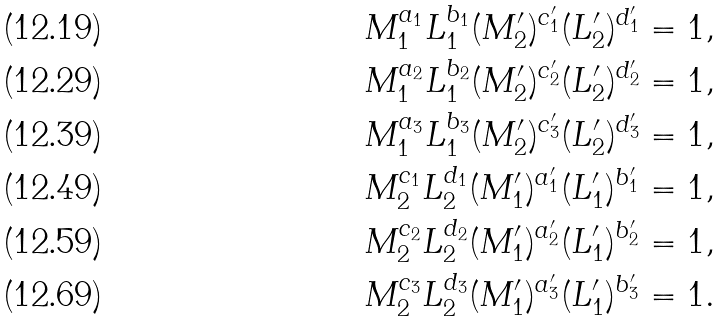Convert formula to latex. <formula><loc_0><loc_0><loc_500><loc_500>M _ { 1 } ^ { a _ { 1 } } L _ { 1 } ^ { b _ { 1 } } ( M ^ { \prime } _ { 2 } ) ^ { c ^ { \prime } _ { 1 } } ( L ^ { \prime } _ { 2 } ) ^ { d ^ { \prime } _ { 1 } } = 1 , \\ M _ { 1 } ^ { a _ { 2 } } L _ { 1 } ^ { b _ { 2 } } ( M ^ { \prime } _ { 2 } ) ^ { c ^ { \prime } _ { 2 } } ( L ^ { \prime } _ { 2 } ) ^ { d ^ { \prime } _ { 2 } } = 1 , \\ M _ { 1 } ^ { a _ { 3 } } L _ { 1 } ^ { b _ { 3 } } ( M ^ { \prime } _ { 2 } ) ^ { c ^ { \prime } _ { 3 } } ( L ^ { \prime } _ { 2 } ) ^ { d ^ { \prime } _ { 3 } } = 1 , \\ M _ { 2 } ^ { c _ { 1 } } L _ { 2 } ^ { d _ { 1 } } ( M ^ { \prime } _ { 1 } ) ^ { a ^ { \prime } _ { 1 } } ( L ^ { \prime } _ { 1 } ) ^ { b ^ { \prime } _ { 1 } } = 1 , \\ M _ { 2 } ^ { c _ { 2 } } L _ { 2 } ^ { d _ { 2 } } ( M ^ { \prime } _ { 1 } ) ^ { a ^ { \prime } _ { 2 } } ( L ^ { \prime } _ { 1 } ) ^ { b ^ { \prime } _ { 2 } } = 1 , \\ M _ { 2 } ^ { c _ { 3 } } L _ { 2 } ^ { d _ { 3 } } ( M ^ { \prime } _ { 1 } ) ^ { a ^ { \prime } _ { 3 } } ( L ^ { \prime } _ { 1 } ) ^ { b ^ { \prime } _ { 3 } } = 1 .</formula> 